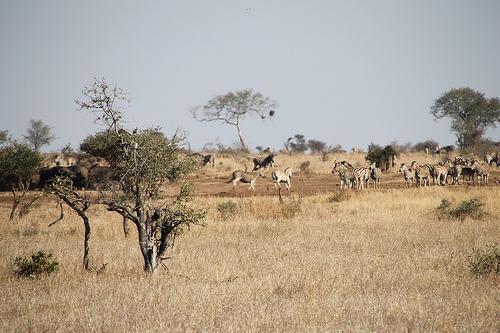How many of the zebras appear to be adolescent?
Give a very brief answer. 2. 